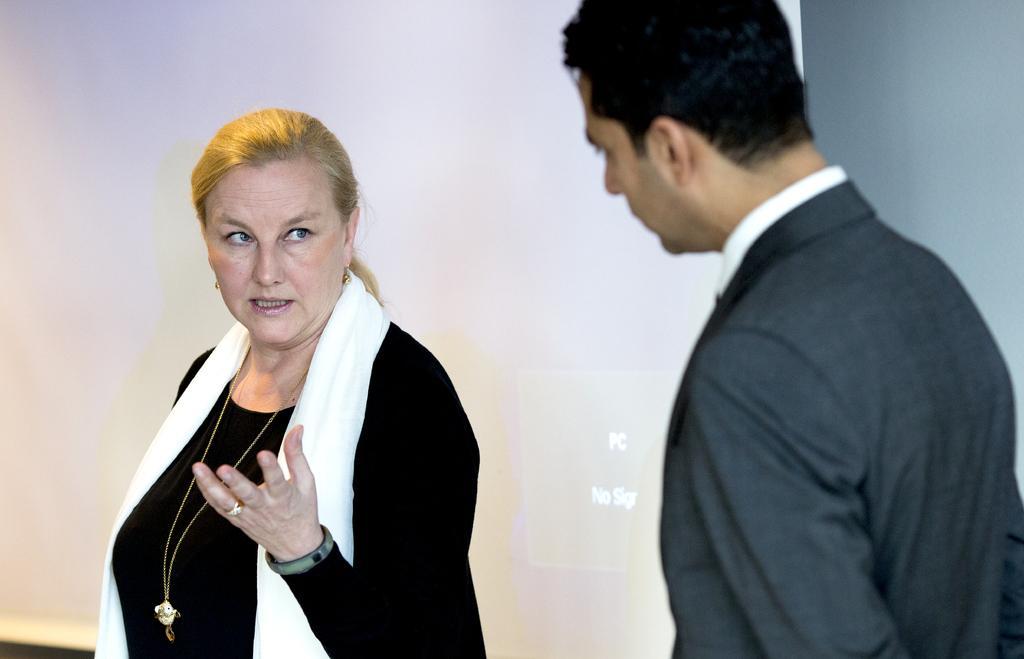In one or two sentences, can you explain what this image depicts? In this image there is a woman wearing a scarf. Right side there is a person wearing a blazer. Behind them there is a screen attached to the wall. 